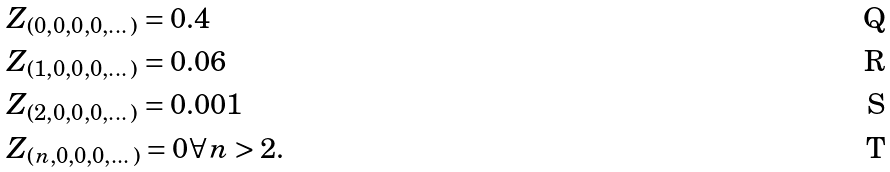Convert formula to latex. <formula><loc_0><loc_0><loc_500><loc_500>& Z _ { ( 0 , 0 , 0 , 0 , \dots ) } = 0 . 4 \\ & Z _ { ( 1 , 0 , 0 , 0 , \dots ) } = 0 . 0 6 \\ & Z _ { ( 2 , 0 , 0 , 0 , \dots ) } = 0 . 0 0 1 \\ & Z _ { ( n , 0 , 0 , 0 , \dots ) } = 0 \forall n > 2 .</formula> 